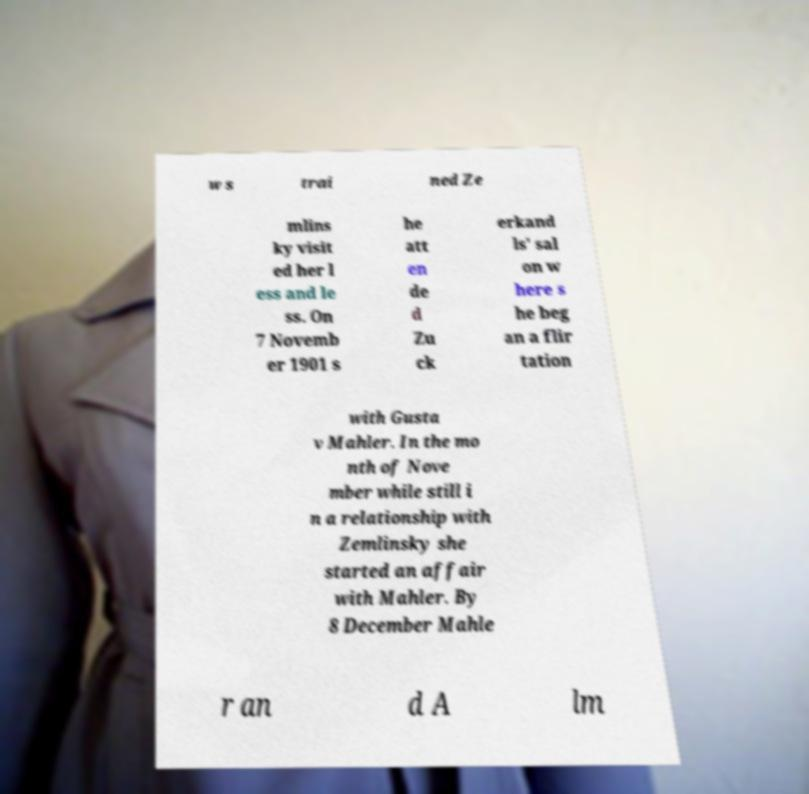Please identify and transcribe the text found in this image. w s trai ned Ze mlins ky visit ed her l ess and le ss. On 7 Novemb er 1901 s he att en de d Zu ck erkand ls' sal on w here s he beg an a flir tation with Gusta v Mahler. In the mo nth of Nove mber while still i n a relationship with Zemlinsky she started an affair with Mahler. By 8 December Mahle r an d A lm 